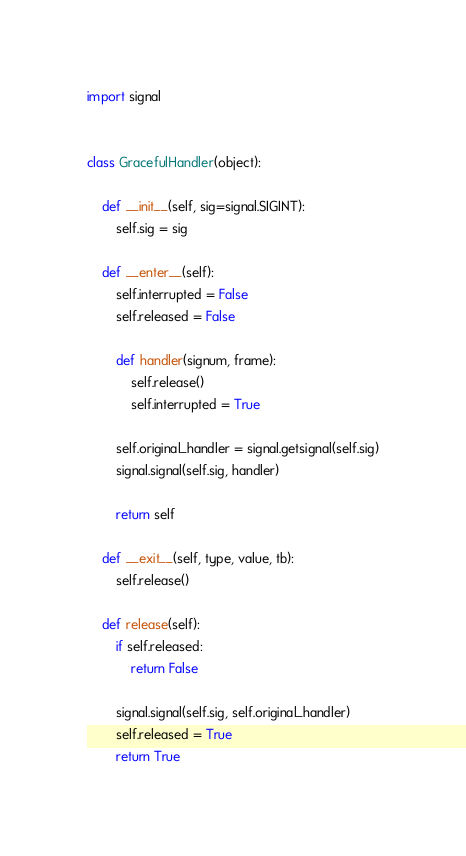<code> <loc_0><loc_0><loc_500><loc_500><_Python_>import signal


class GracefulHandler(object):

    def __init__(self, sig=signal.SIGINT):
        self.sig = sig

    def __enter__(self):
        self.interrupted = False
        self.released = False

        def handler(signum, frame):
            self.release()
            self.interrupted = True

        self.original_handler = signal.getsignal(self.sig)
        signal.signal(self.sig, handler)

        return self

    def __exit__(self, type, value, tb):
        self.release()

    def release(self):
        if self.released:
            return False

        signal.signal(self.sig, self.original_handler)
        self.released = True
        return True
</code> 